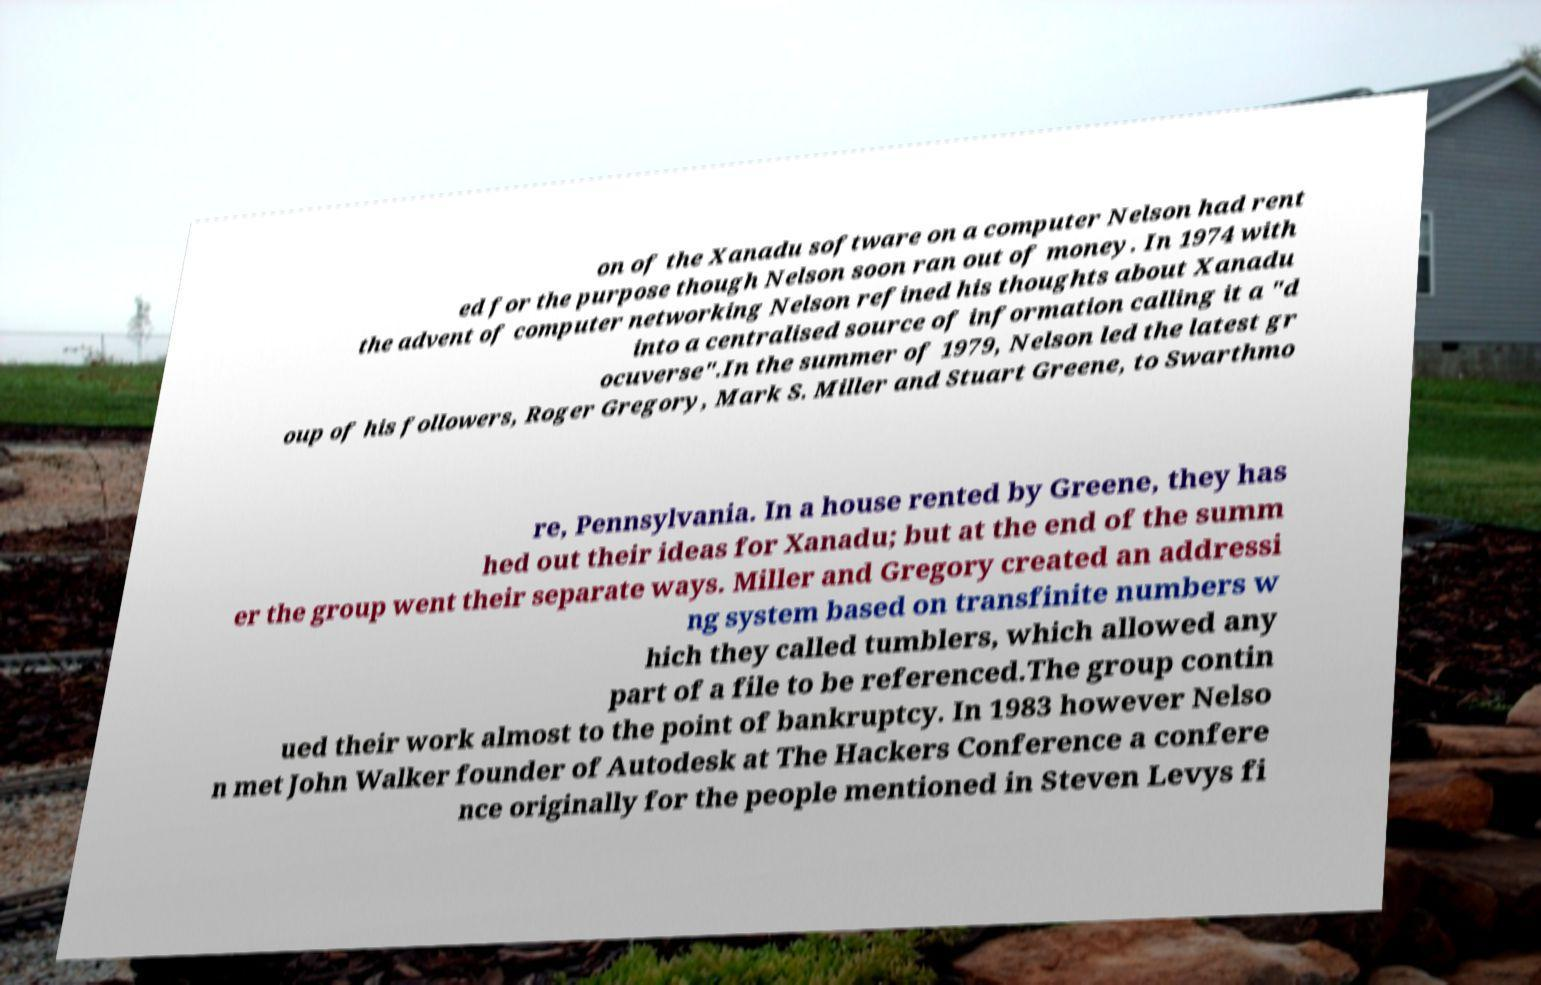Could you assist in decoding the text presented in this image and type it out clearly? on of the Xanadu software on a computer Nelson had rent ed for the purpose though Nelson soon ran out of money. In 1974 with the advent of computer networking Nelson refined his thoughts about Xanadu into a centralised source of information calling it a "d ocuverse".In the summer of 1979, Nelson led the latest gr oup of his followers, Roger Gregory, Mark S. Miller and Stuart Greene, to Swarthmo re, Pennsylvania. In a house rented by Greene, they has hed out their ideas for Xanadu; but at the end of the summ er the group went their separate ways. Miller and Gregory created an addressi ng system based on transfinite numbers w hich they called tumblers, which allowed any part of a file to be referenced.The group contin ued their work almost to the point of bankruptcy. In 1983 however Nelso n met John Walker founder of Autodesk at The Hackers Conference a confere nce originally for the people mentioned in Steven Levys fi 